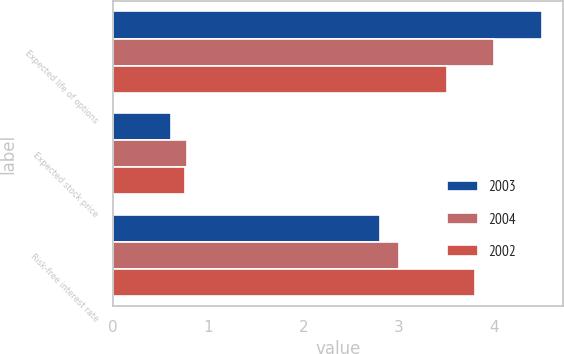Convert chart. <chart><loc_0><loc_0><loc_500><loc_500><stacked_bar_chart><ecel><fcel>Expected life of options<fcel>Expected stock price<fcel>Risk-free interest rate<nl><fcel>2003<fcel>4.5<fcel>0.61<fcel>2.8<nl><fcel>2004<fcel>4<fcel>0.78<fcel>3<nl><fcel>2002<fcel>3.5<fcel>0.76<fcel>3.8<nl></chart> 